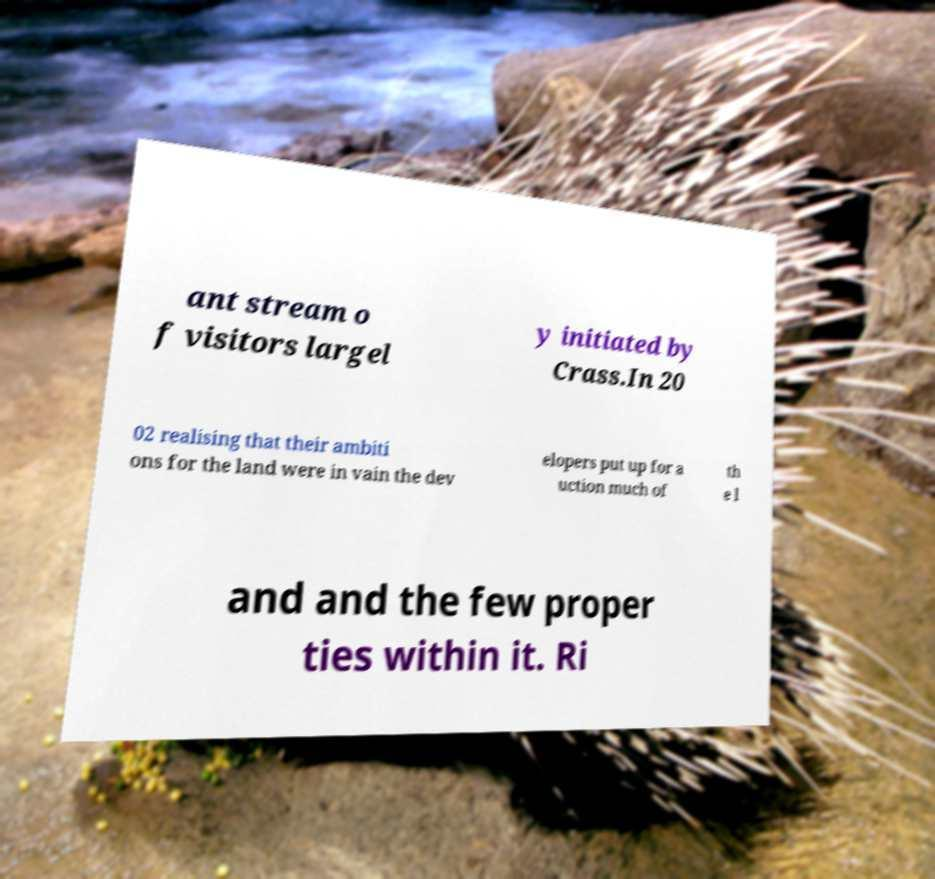Can you accurately transcribe the text from the provided image for me? ant stream o f visitors largel y initiated by Crass.In 20 02 realising that their ambiti ons for the land were in vain the dev elopers put up for a uction much of th e l and and the few proper ties within it. Ri 